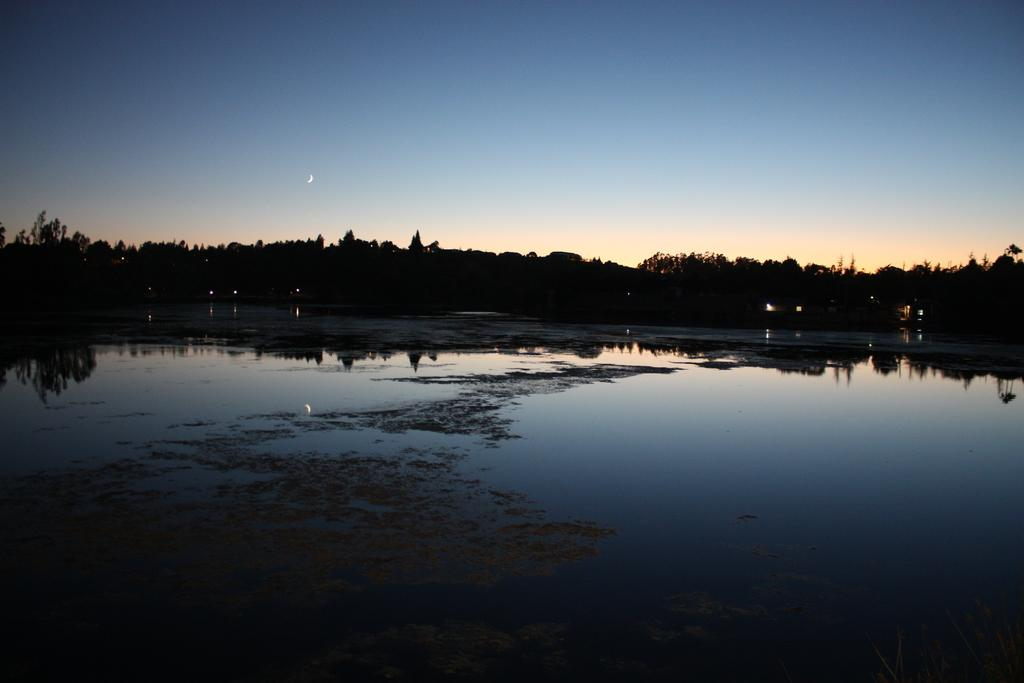What is visible in the image? Water is visible in the image. What can be seen in the background of the image? There are vehicles and trees in the background of the image. What is the color of the sky in the image? The sky is blue and white in color. What type of furniture can be seen in the image? There is no furniture present in the image. What game is being played in the image? There is no game being played in the image. 